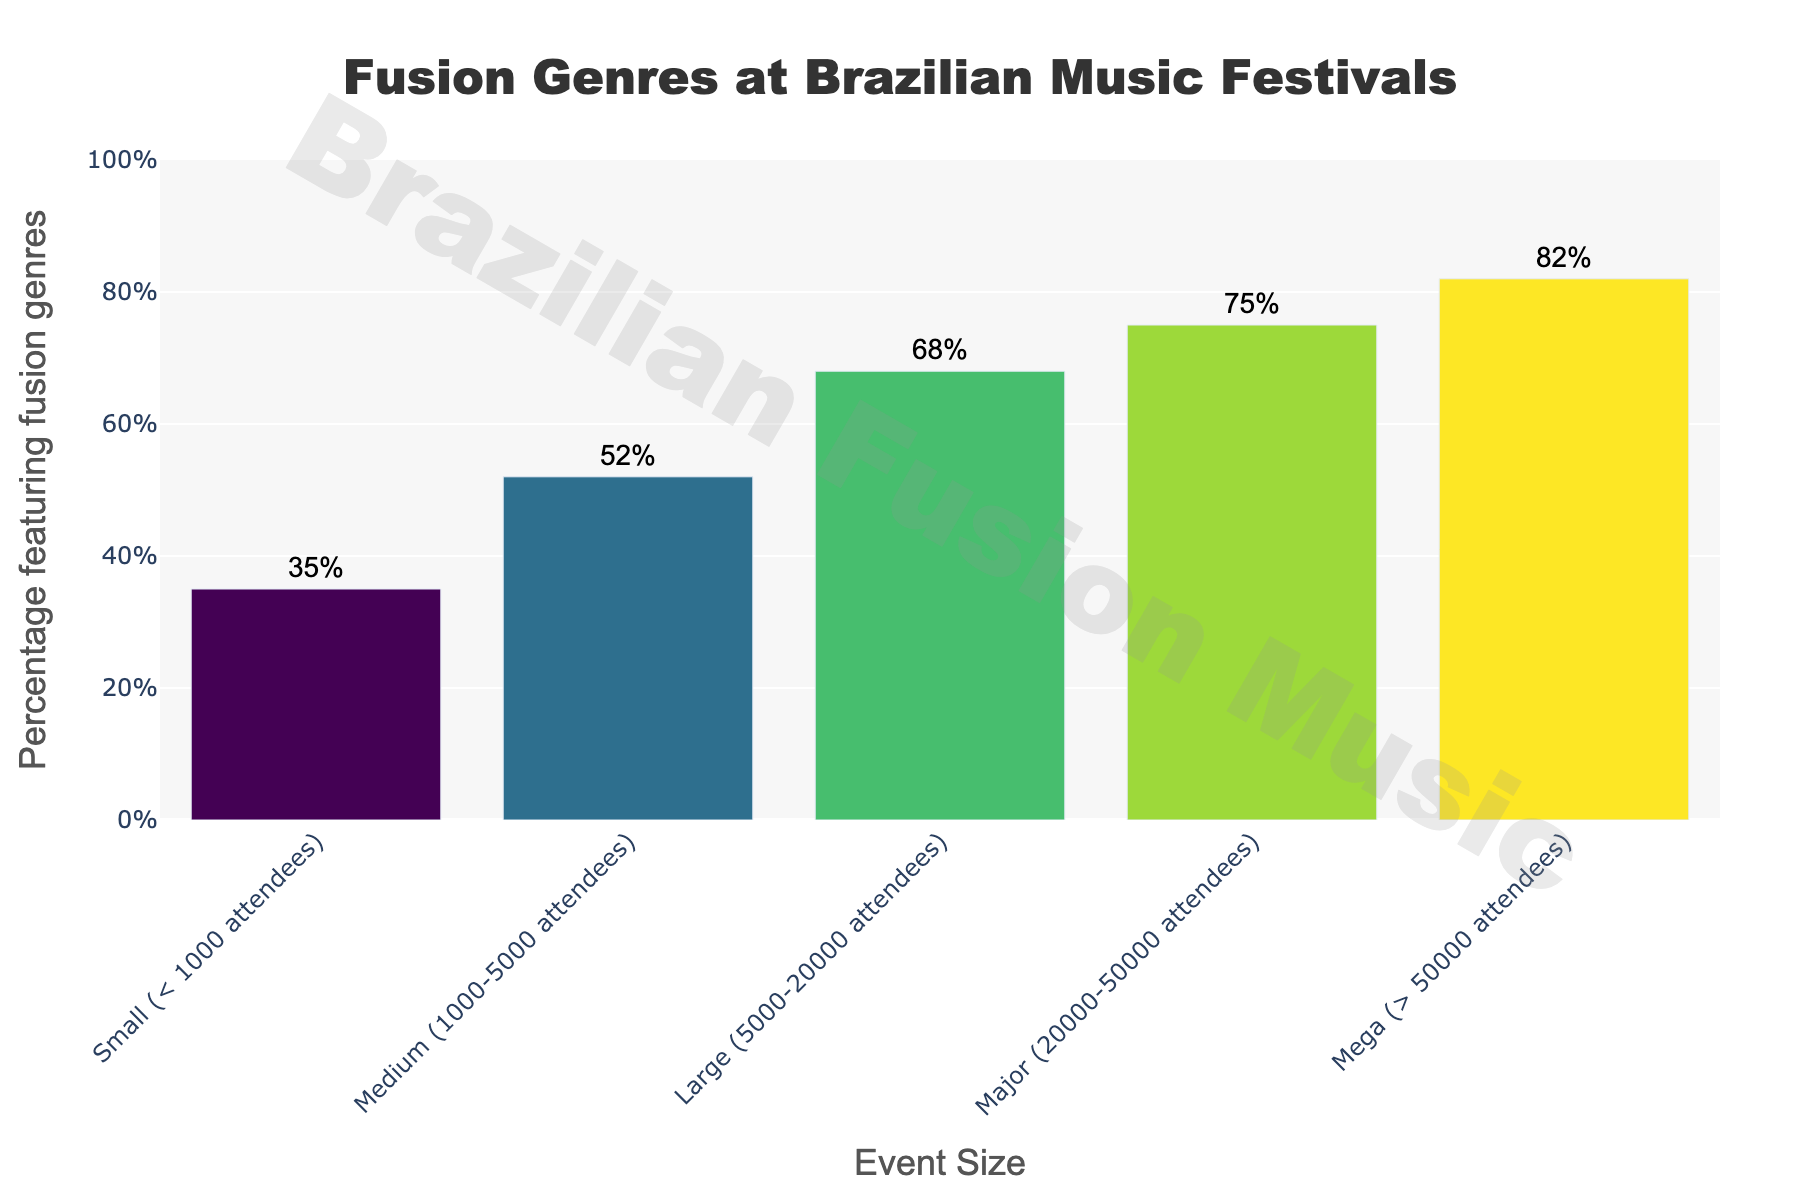what percentage of large events feature fusion genres? Look at the bar representing large events and read the percentage indicated.
Answer: 68% which event size has the highest percentage of festivals featuring fusion genres? Compare the percentages of each event size and identify the highest one.
Answer: Mega (> 50000 attendees) which event size category has a percentage closest to the average percentage of all categories? Calculate the average percentage: (35 + 52 + 68 + 75 + 82) / 5 = 62. Then see which percentage is closest to 62.
Answer: Medium (1000-5000 attendees) what is the difference in percentage between small and major events? Subtract the percentage of small events from the percentage of major events: 75 - 35 = 40
Answer: 40% are there any event sizes with a percentage of fusion genre festivals between 60% and 70%? Look at the percentages for each event size and identify any that fall between 60% and 70%.
Answer: Yes, Large (5000-20000 attendees) what is the total percentage of events (all sizes) featuring fusion genres? Add up all the percentages regardless of size: 35 + 52 + 68 + 75 + 82 = 312
Answer: 312% how does the percentage change from medium to large events? Subtract the percentage for medium events from the percentage for large events: 68 - 52 = 16
Answer: 16% what’s the combined percentage for all events smaller than large events? Add the percentages for small and medium-sized events: 35 + 52 = 87
Answer: 87% what can be inferred about the trend in the percentage of fusion events as event size increases? Observe the pattern in the data: 35%, 52%, 68%, 75%, 82%. The percentage increases as the event size increases.
Answer: The percentage increases with event size 